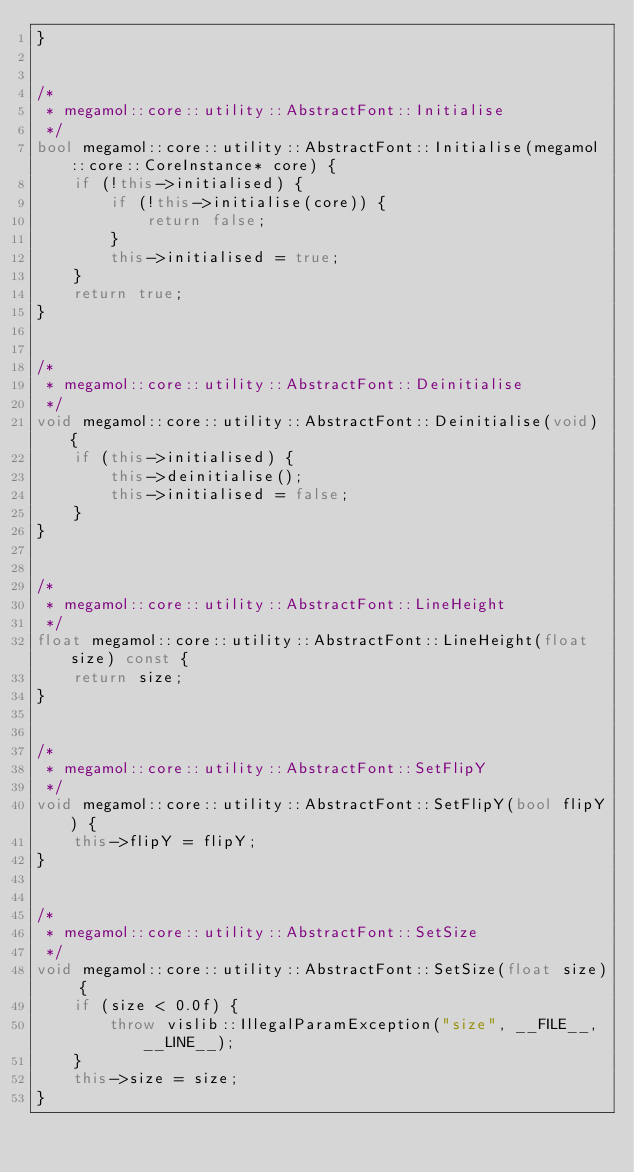Convert code to text. <code><loc_0><loc_0><loc_500><loc_500><_C++_>}


/*
 * megamol::core::utility::AbstractFont::Initialise
 */
bool megamol::core::utility::AbstractFont::Initialise(megamol::core::CoreInstance* core) {
    if (!this->initialised) {
        if (!this->initialise(core)) {
            return false;
        }
        this->initialised = true;
    }
    return true;
}


/*
 * megamol::core::utility::AbstractFont::Deinitialise
 */
void megamol::core::utility::AbstractFont::Deinitialise(void) {
    if (this->initialised) {
        this->deinitialise();
        this->initialised = false;
    }
}


/*
 * megamol::core::utility::AbstractFont::LineHeight
 */
float megamol::core::utility::AbstractFont::LineHeight(float size) const {
    return size;
}


/*
 * megamol::core::utility::AbstractFont::SetFlipY
 */
void megamol::core::utility::AbstractFont::SetFlipY(bool flipY) {
    this->flipY = flipY;
}


/*
 * megamol::core::utility::AbstractFont::SetSize
 */
void megamol::core::utility::AbstractFont::SetSize(float size) {
    if (size < 0.0f) {
        throw vislib::IllegalParamException("size", __FILE__, __LINE__);
    }
    this->size = size;
}
</code> 